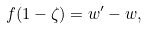Convert formula to latex. <formula><loc_0><loc_0><loc_500><loc_500>f ( 1 - \zeta ) = w ^ { \prime } - w ,</formula> 